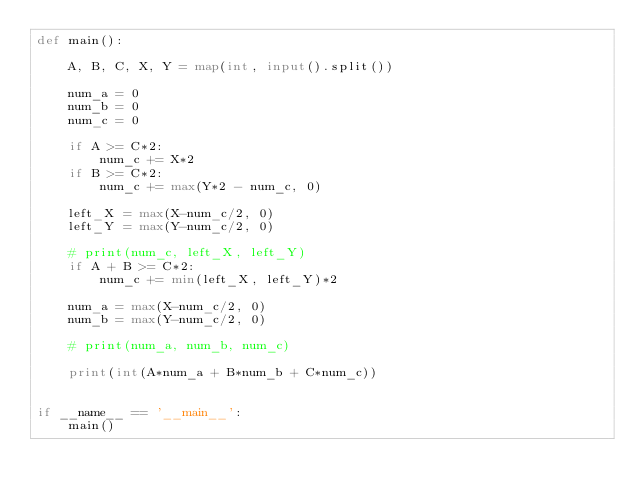<code> <loc_0><loc_0><loc_500><loc_500><_Python_>def main():

    A, B, C, X, Y = map(int, input().split())

    num_a = 0
    num_b = 0
    num_c = 0

    if A >= C*2:
        num_c += X*2
    if B >= C*2:
        num_c += max(Y*2 - num_c, 0)

    left_X = max(X-num_c/2, 0)
    left_Y = max(Y-num_c/2, 0)

    # print(num_c, left_X, left_Y)
    if A + B >= C*2:
        num_c += min(left_X, left_Y)*2

    num_a = max(X-num_c/2, 0)
    num_b = max(Y-num_c/2, 0)

    # print(num_a, num_b, num_c)

    print(int(A*num_a + B*num_b + C*num_c))


if __name__ == '__main__':
    main()</code> 